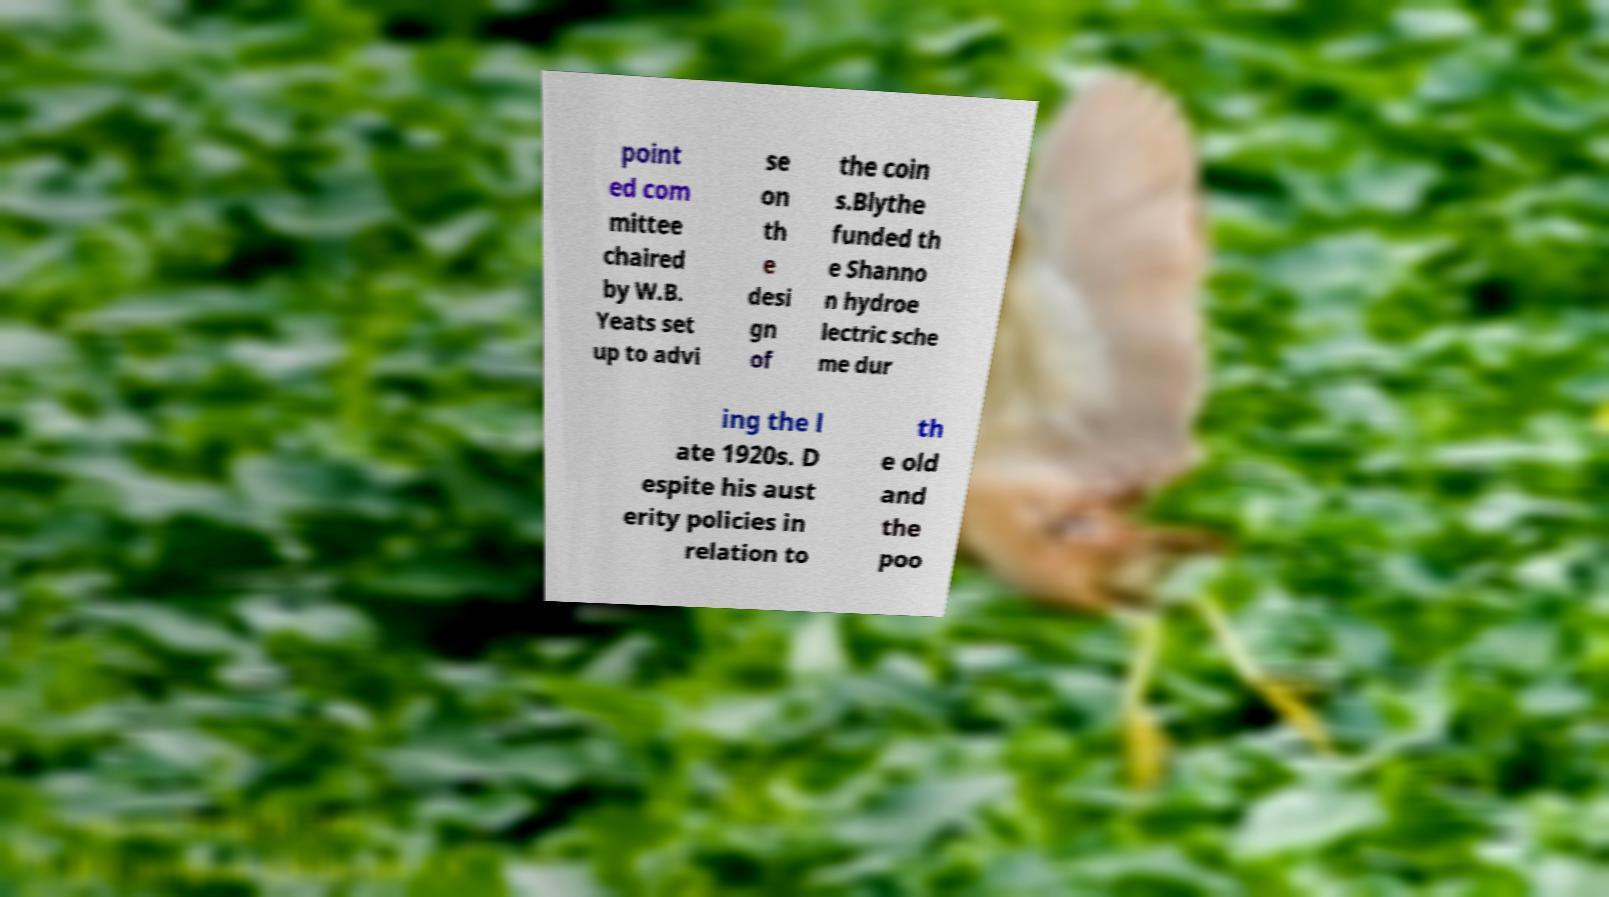What messages or text are displayed in this image? I need them in a readable, typed format. point ed com mittee chaired by W.B. Yeats set up to advi se on th e desi gn of the coin s.Blythe funded th e Shanno n hydroe lectric sche me dur ing the l ate 1920s. D espite his aust erity policies in relation to th e old and the poo 